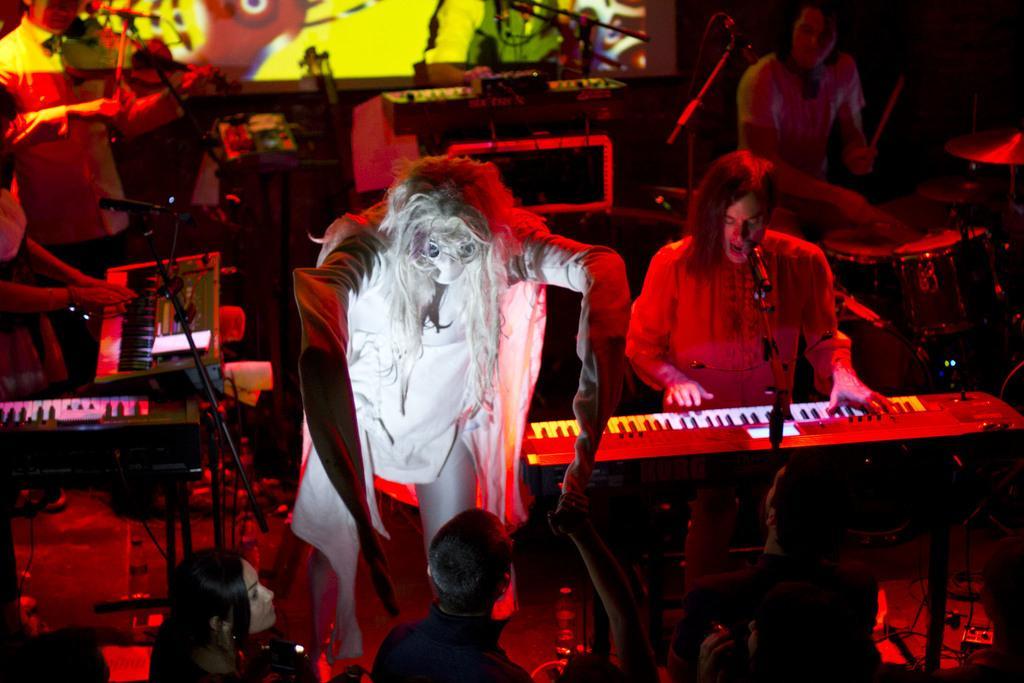Could you give a brief overview of what you see in this image? In this image there is a person dressed in Halloween costume is performing on the stage, behind him there are few musicians playing keyboard and drums. 